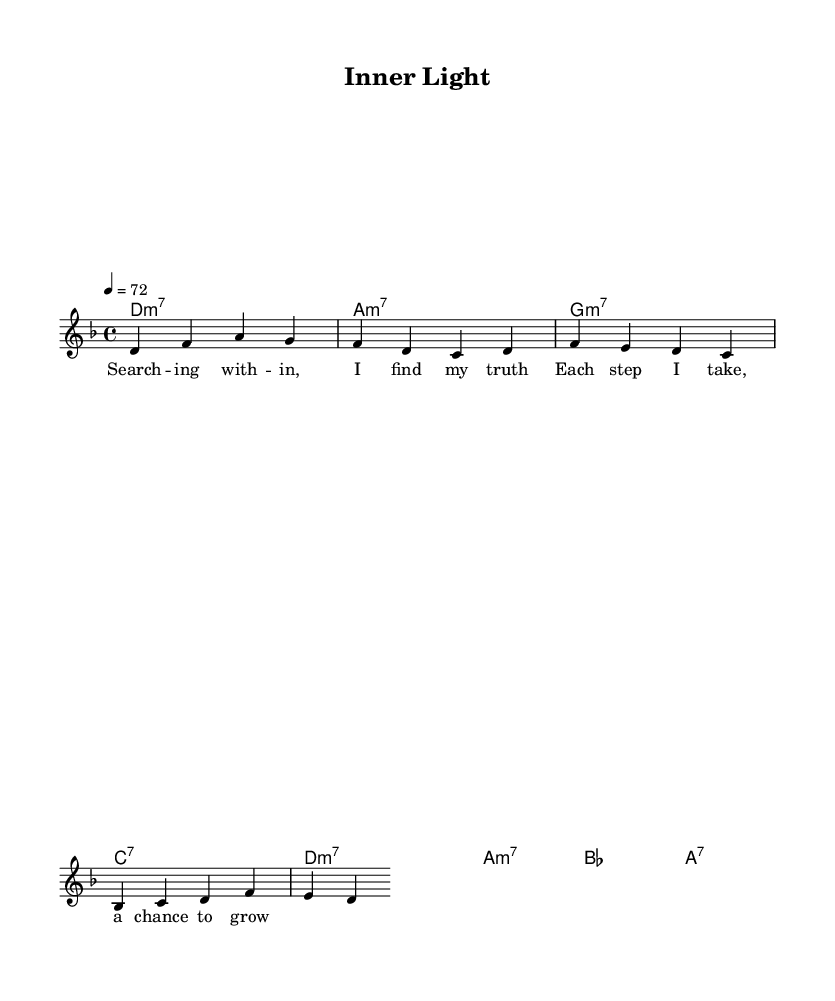What is the key signature of this music? The key signature is indicated by the key signature clef and is marked with d minor, which has one flat (B).
Answer: d minor What is the time signature of this music? The time signature is shown at the beginning of the score and is indicated as 4/4, meaning there are four beats in each measure and the quarter note gets one beat.
Answer: 4/4 What is the tempo of this music? The tempo marking indicates a speed of 72 beats per minute, which is expressed in the score as "4 = 72."
Answer: 72 How many measures are in the melody? By counting the measures in the melody line, there are a total of 4 measures shown in the score.
Answer: 4 What chord follows the D minor 7 chord? The chord progression shows that the D minor 7 chord is followed by an A minor 7 chord, as indicated in the harmonies section.
Answer: A minor 7 What theme is the lyrics primarily focused on? The lyrics express a theme of self-discovery and personal growth, stating the process of finding one's truth and the opportunities for growth.
Answer: Self-discovery What type of musical form does this piece reflect? The piece utilizes a typical verse structure common in Rhythm and Blues, focusing on lyrical expression and melodic movement.
Answer: Verse structure 